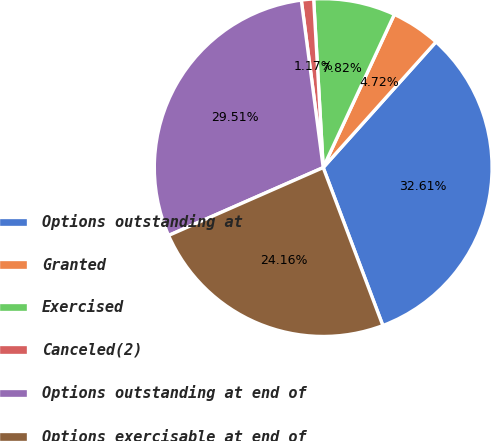<chart> <loc_0><loc_0><loc_500><loc_500><pie_chart><fcel>Options outstanding at<fcel>Granted<fcel>Exercised<fcel>Canceled(2)<fcel>Options outstanding at end of<fcel>Options exercisable at end of<nl><fcel>32.61%<fcel>4.72%<fcel>7.82%<fcel>1.17%<fcel>29.51%<fcel>24.16%<nl></chart> 